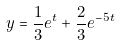<formula> <loc_0><loc_0><loc_500><loc_500>y = \frac { 1 } { 3 } e ^ { t } + \frac { 2 } { 3 } e ^ { - 5 t }</formula> 